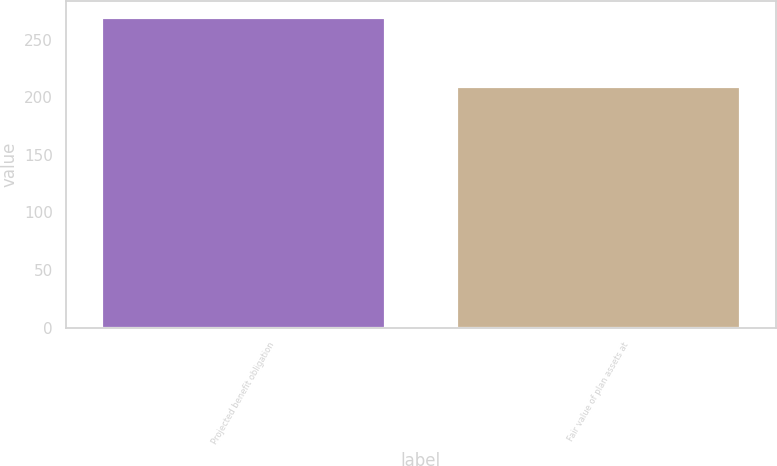Convert chart to OTSL. <chart><loc_0><loc_0><loc_500><loc_500><bar_chart><fcel>Projected benefit obligation<fcel>Fair value of plan assets at<nl><fcel>270<fcel>210<nl></chart> 